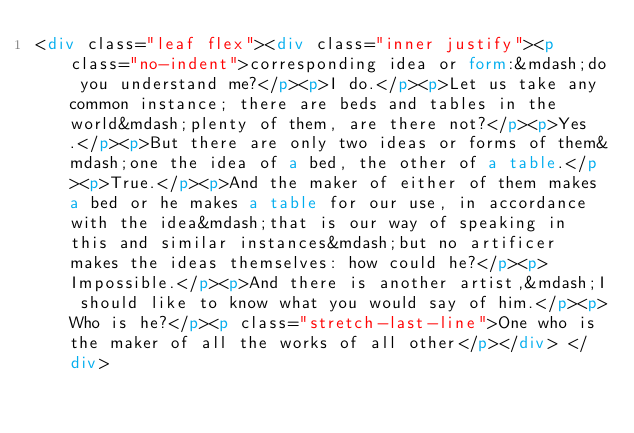<code> <loc_0><loc_0><loc_500><loc_500><_HTML_><div class="leaf flex"><div class="inner justify"><p class="no-indent">corresponding idea or form:&mdash;do you understand me?</p><p>I do.</p><p>Let us take any common instance; there are beds and tables in the world&mdash;plenty of them, are there not?</p><p>Yes.</p><p>But there are only two ideas or forms of them&mdash;one the idea of a bed, the other of a table.</p><p>True.</p><p>And the maker of either of them makes a bed or he makes a table for our use, in accordance with the idea&mdash;that is our way of speaking in this and similar instances&mdash;but no artificer makes the ideas themselves: how could he?</p><p>Impossible.</p><p>And there is another artist,&mdash;I should like to know what you would say of him.</p><p>Who is he?</p><p class="stretch-last-line">One who is the maker of all the works of all other</p></div> </div></code> 